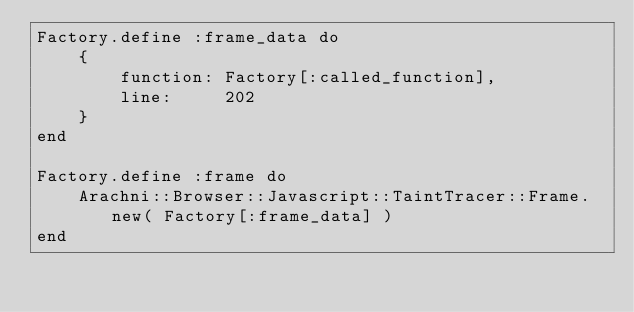Convert code to text. <code><loc_0><loc_0><loc_500><loc_500><_Ruby_>Factory.define :frame_data do
    {
        function: Factory[:called_function],
        line:     202
    }
end

Factory.define :frame do
    Arachni::Browser::Javascript::TaintTracer::Frame.new( Factory[:frame_data] )
end
</code> 